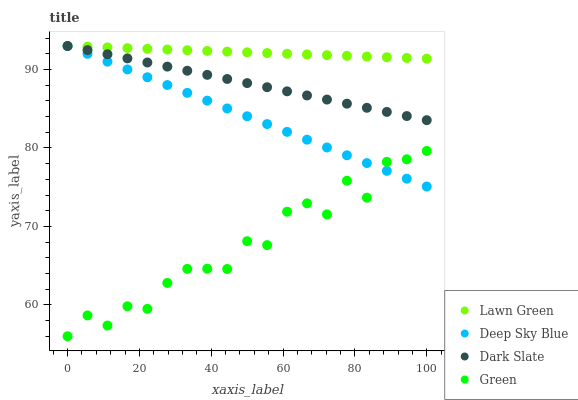Does Green have the minimum area under the curve?
Answer yes or no. Yes. Does Lawn Green have the maximum area under the curve?
Answer yes or no. Yes. Does Deep Sky Blue have the minimum area under the curve?
Answer yes or no. No. Does Deep Sky Blue have the maximum area under the curve?
Answer yes or no. No. Is Deep Sky Blue the smoothest?
Answer yes or no. Yes. Is Green the roughest?
Answer yes or no. Yes. Is Green the smoothest?
Answer yes or no. No. Is Deep Sky Blue the roughest?
Answer yes or no. No. Does Green have the lowest value?
Answer yes or no. Yes. Does Deep Sky Blue have the lowest value?
Answer yes or no. No. Does Dark Slate have the highest value?
Answer yes or no. Yes. Does Green have the highest value?
Answer yes or no. No. Is Green less than Dark Slate?
Answer yes or no. Yes. Is Lawn Green greater than Green?
Answer yes or no. Yes. Does Dark Slate intersect Lawn Green?
Answer yes or no. Yes. Is Dark Slate less than Lawn Green?
Answer yes or no. No. Is Dark Slate greater than Lawn Green?
Answer yes or no. No. Does Green intersect Dark Slate?
Answer yes or no. No. 